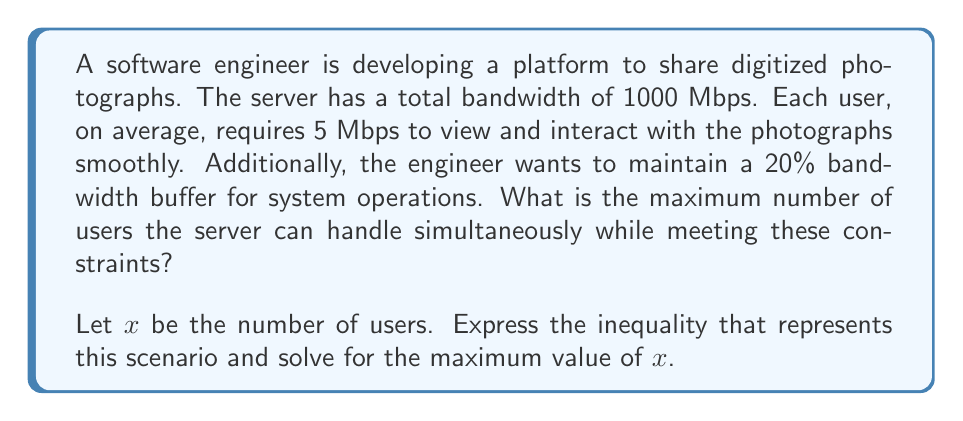Can you solve this math problem? Let's approach this step-by-step:

1) First, let's set up our inequality:
   
   $5x + 0.2(1000) \leq 1000$

   Where:
   - $5x$ represents the bandwidth used by users (5 Mbps per user)
   - $0.2(1000)$ represents the 20% bandwidth buffer (200 Mbps)
   - $1000$ is the total available bandwidth

2) Simplify the right side of the inequality:
   
   $5x + 200 \leq 1000$

3) Subtract 200 from both sides:
   
   $5x \leq 800$

4) Divide both sides by 5:
   
   $x \leq 160$

5) Since we're looking for the maximum number of users, and $x$ represents the number of users, we want the largest integer value that satisfies this inequality.

Therefore, the maximum number of users is 160.

To verify:
$(160 * 5) + 200 = 1000$, which uses exactly the available bandwidth.
$(161 * 5) + 200 = 1005$, which would exceed the available bandwidth.
Answer: The maximum number of users the server can handle simultaneously is 160. 